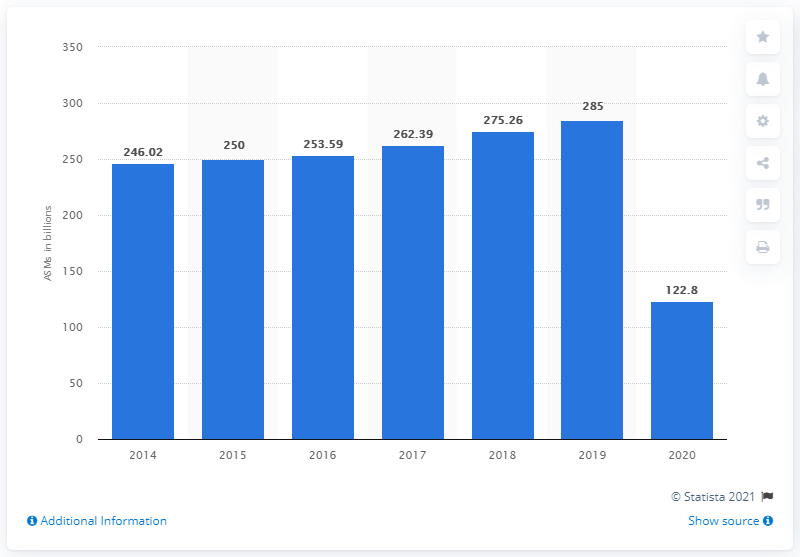Indicate a few pertinent items in this graphic. In the fiscal year of 2020, United Airlines had 122.8 ASMs. 